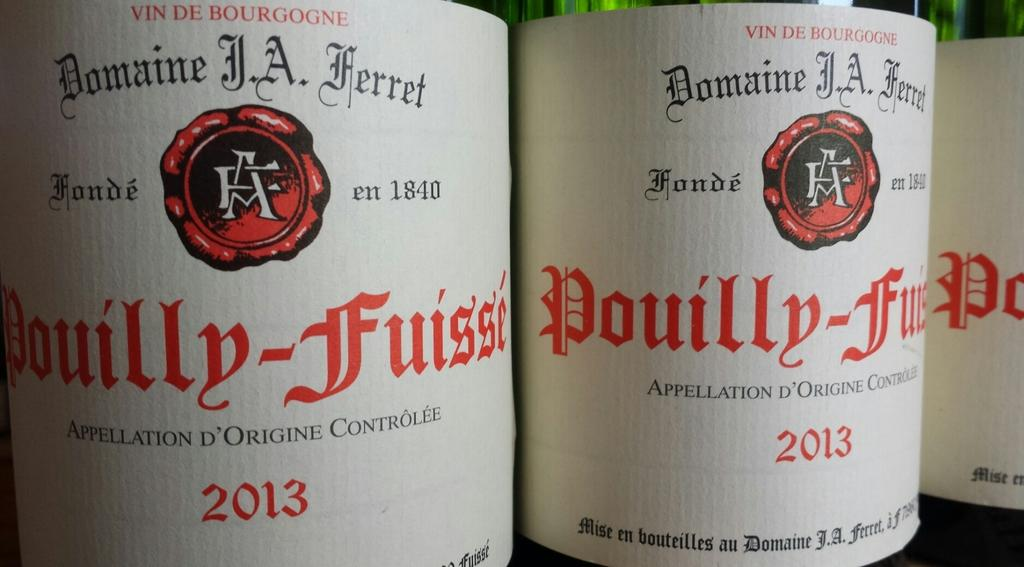<image>
Offer a succinct explanation of the picture presented. Three large bottles of Pouilly-Fuisse are positioned closely together. 